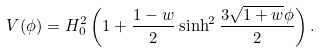<formula> <loc_0><loc_0><loc_500><loc_500>V ( \phi ) = H _ { 0 } ^ { 2 } \left ( 1 + \frac { 1 - w } { 2 } \sinh ^ { 2 } \frac { 3 \sqrt { 1 + w } \phi } { 2 } \right ) .</formula> 